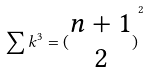Convert formula to latex. <formula><loc_0><loc_0><loc_500><loc_500>\sum k ^ { 3 } = { ( \begin{matrix} n + 1 \\ 2 \end{matrix} ) } ^ { 2 }</formula> 